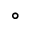<formula> <loc_0><loc_0><loc_500><loc_500>^ { \circ }</formula> 